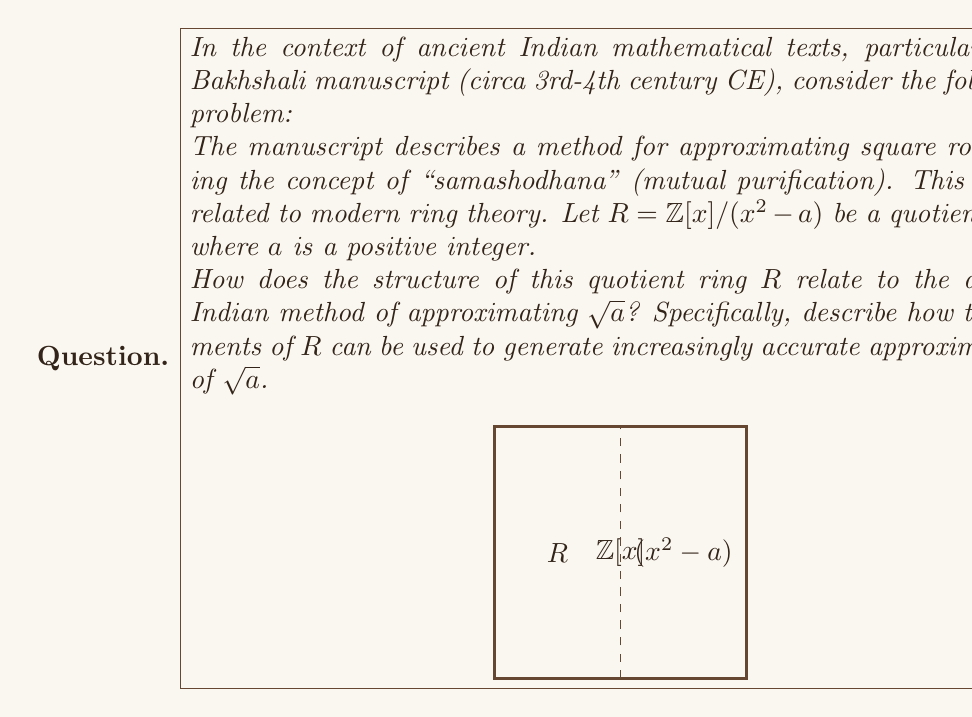What is the answer to this math problem? To understand the connection between the quotient ring $R = \mathbb{Z}[x]/(x^2 - a)$ and the ancient Indian method of approximating $\sqrt{a}$, we need to follow these steps:

1) In the quotient ring $R$, we have $x^2 \equiv a \pmod{(x^2 - a)}$. This means that $x$ represents a "formal" square root of $a$ in $R$.

2) The ancient Indian method of "samashodhana" involves starting with an initial approximation and iteratively improving it. In modern terms, this is similar to Newton's method.

3) Let's represent a general element of $R$ as $p + qx$, where $p, q \in \mathbb{Z}$. This element can be thought of as an approximation to $\sqrt{a}$ in the form $p + q\sqrt{a}$.

4) The key insight is that if $p + q\sqrt{a}$ is close to $\sqrt{a}$, then its reciprocal $(p - q\sqrt{a})/(p^2 - aq^2)$ is also close to $1/\sqrt{a}$.

5) This leads to the iteration formula:

   $$(p_n + q_nx) \cdot \frac{p_n - q_nx}{p_n^2 - aq_n^2} = \frac{p_n^2 + aq_n^2}{p_n^2 - aq_n^2} + \frac{2p_nq_n}{p_n^2 - aq_n^2}x$$

6) The rational part of this expression, $(p_n^2 + aq_n^2)/(p_n^2 - aq_n^2)$, gives an improved approximation for $a$.

7) By repeatedly applying this operation in $R$, we generate a sequence of elements that correspond to increasingly accurate approximations of $\sqrt{a}$.

This method, encoded in the structure of the quotient ring $R$, essentially captures the ancient Indian algorithm for approximating square roots, demonstrating a remarkable connection between ancient mathematical practices and modern algebraic structures.
Answer: The quotient ring $R = \mathbb{Z}[x]/(x^2 - a)$ encodes the ancient Indian "samashodhana" method for approximating $\sqrt{a}$ by representing $\sqrt{a}$ as a formal element $x$ and using the ring structure to generate iterative approximations. 